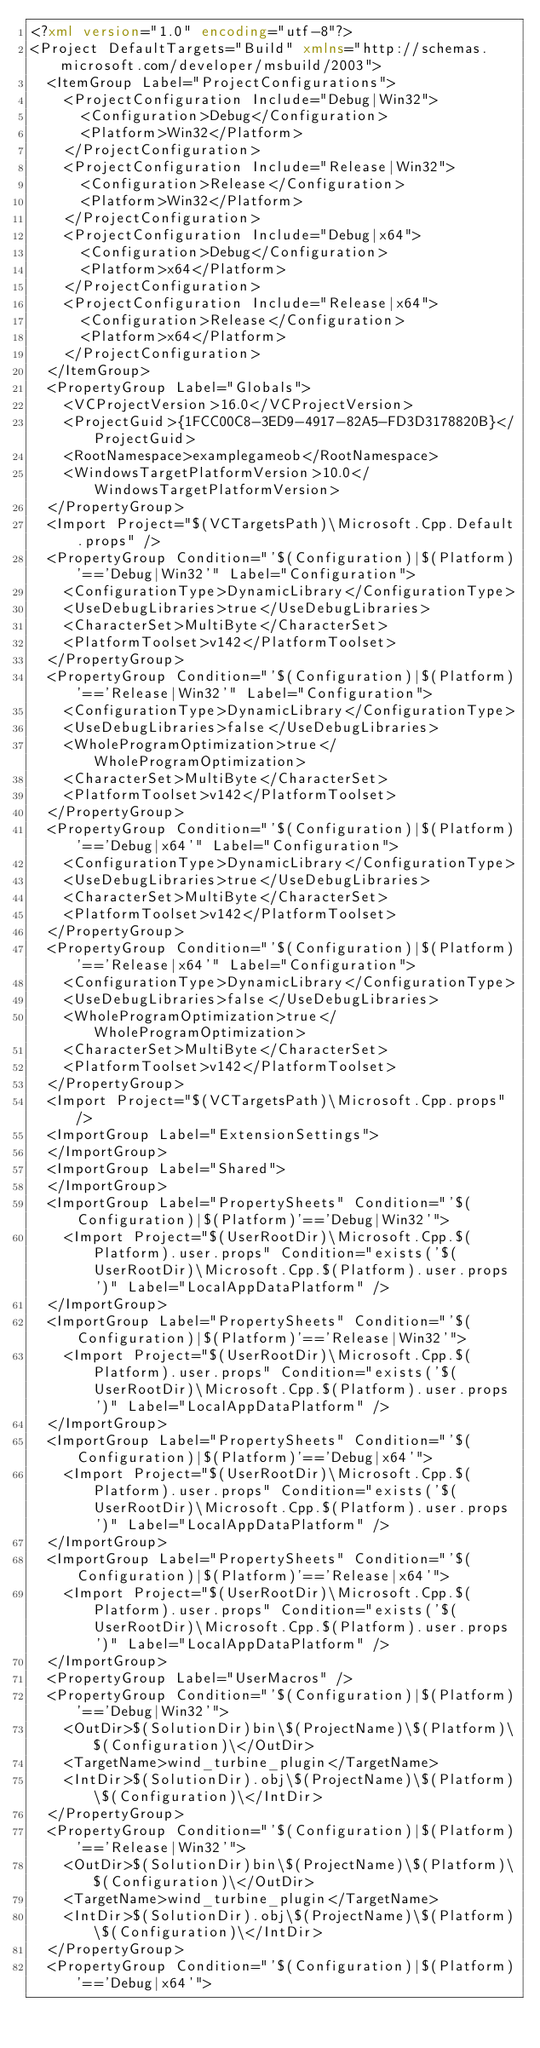<code> <loc_0><loc_0><loc_500><loc_500><_XML_><?xml version="1.0" encoding="utf-8"?>
<Project DefaultTargets="Build" xmlns="http://schemas.microsoft.com/developer/msbuild/2003">
  <ItemGroup Label="ProjectConfigurations">
    <ProjectConfiguration Include="Debug|Win32">
      <Configuration>Debug</Configuration>
      <Platform>Win32</Platform>
    </ProjectConfiguration>
    <ProjectConfiguration Include="Release|Win32">
      <Configuration>Release</Configuration>
      <Platform>Win32</Platform>
    </ProjectConfiguration>
    <ProjectConfiguration Include="Debug|x64">
      <Configuration>Debug</Configuration>
      <Platform>x64</Platform>
    </ProjectConfiguration>
    <ProjectConfiguration Include="Release|x64">
      <Configuration>Release</Configuration>
      <Platform>x64</Platform>
    </ProjectConfiguration>
  </ItemGroup>
  <PropertyGroup Label="Globals">
    <VCProjectVersion>16.0</VCProjectVersion>
    <ProjectGuid>{1FCC00C8-3ED9-4917-82A5-FD3D3178820B}</ProjectGuid>
    <RootNamespace>examplegameob</RootNamespace>
    <WindowsTargetPlatformVersion>10.0</WindowsTargetPlatformVersion>
  </PropertyGroup>
  <Import Project="$(VCTargetsPath)\Microsoft.Cpp.Default.props" />
  <PropertyGroup Condition="'$(Configuration)|$(Platform)'=='Debug|Win32'" Label="Configuration">
    <ConfigurationType>DynamicLibrary</ConfigurationType>
    <UseDebugLibraries>true</UseDebugLibraries>
    <CharacterSet>MultiByte</CharacterSet>
    <PlatformToolset>v142</PlatformToolset>
  </PropertyGroup>
  <PropertyGroup Condition="'$(Configuration)|$(Platform)'=='Release|Win32'" Label="Configuration">
    <ConfigurationType>DynamicLibrary</ConfigurationType>
    <UseDebugLibraries>false</UseDebugLibraries>
    <WholeProgramOptimization>true</WholeProgramOptimization>
    <CharacterSet>MultiByte</CharacterSet>
    <PlatformToolset>v142</PlatformToolset>
  </PropertyGroup>
  <PropertyGroup Condition="'$(Configuration)|$(Platform)'=='Debug|x64'" Label="Configuration">
    <ConfigurationType>DynamicLibrary</ConfigurationType>
    <UseDebugLibraries>true</UseDebugLibraries>
    <CharacterSet>MultiByte</CharacterSet>
    <PlatformToolset>v142</PlatformToolset>
  </PropertyGroup>
  <PropertyGroup Condition="'$(Configuration)|$(Platform)'=='Release|x64'" Label="Configuration">
    <ConfigurationType>DynamicLibrary</ConfigurationType>
    <UseDebugLibraries>false</UseDebugLibraries>
    <WholeProgramOptimization>true</WholeProgramOptimization>
    <CharacterSet>MultiByte</CharacterSet>
    <PlatformToolset>v142</PlatformToolset>
  </PropertyGroup>
  <Import Project="$(VCTargetsPath)\Microsoft.Cpp.props" />
  <ImportGroup Label="ExtensionSettings">
  </ImportGroup>
  <ImportGroup Label="Shared">
  </ImportGroup>
  <ImportGroup Label="PropertySheets" Condition="'$(Configuration)|$(Platform)'=='Debug|Win32'">
    <Import Project="$(UserRootDir)\Microsoft.Cpp.$(Platform).user.props" Condition="exists('$(UserRootDir)\Microsoft.Cpp.$(Platform).user.props')" Label="LocalAppDataPlatform" />
  </ImportGroup>
  <ImportGroup Label="PropertySheets" Condition="'$(Configuration)|$(Platform)'=='Release|Win32'">
    <Import Project="$(UserRootDir)\Microsoft.Cpp.$(Platform).user.props" Condition="exists('$(UserRootDir)\Microsoft.Cpp.$(Platform).user.props')" Label="LocalAppDataPlatform" />
  </ImportGroup>
  <ImportGroup Label="PropertySheets" Condition="'$(Configuration)|$(Platform)'=='Debug|x64'">
    <Import Project="$(UserRootDir)\Microsoft.Cpp.$(Platform).user.props" Condition="exists('$(UserRootDir)\Microsoft.Cpp.$(Platform).user.props')" Label="LocalAppDataPlatform" />
  </ImportGroup>
  <ImportGroup Label="PropertySheets" Condition="'$(Configuration)|$(Platform)'=='Release|x64'">
    <Import Project="$(UserRootDir)\Microsoft.Cpp.$(Platform).user.props" Condition="exists('$(UserRootDir)\Microsoft.Cpp.$(Platform).user.props')" Label="LocalAppDataPlatform" />
  </ImportGroup>
  <PropertyGroup Label="UserMacros" />
  <PropertyGroup Condition="'$(Configuration)|$(Platform)'=='Debug|Win32'">
    <OutDir>$(SolutionDir)bin\$(ProjectName)\$(Platform)\$(Configuration)\</OutDir>
    <TargetName>wind_turbine_plugin</TargetName>
    <IntDir>$(SolutionDir).obj\$(ProjectName)\$(Platform)\$(Configuration)\</IntDir>
  </PropertyGroup>
  <PropertyGroup Condition="'$(Configuration)|$(Platform)'=='Release|Win32'">
    <OutDir>$(SolutionDir)bin\$(ProjectName)\$(Platform)\$(Configuration)\</OutDir>
    <TargetName>wind_turbine_plugin</TargetName>
    <IntDir>$(SolutionDir).obj\$(ProjectName)\$(Platform)\$(Configuration)\</IntDir>
  </PropertyGroup>
  <PropertyGroup Condition="'$(Configuration)|$(Platform)'=='Debug|x64'"></code> 